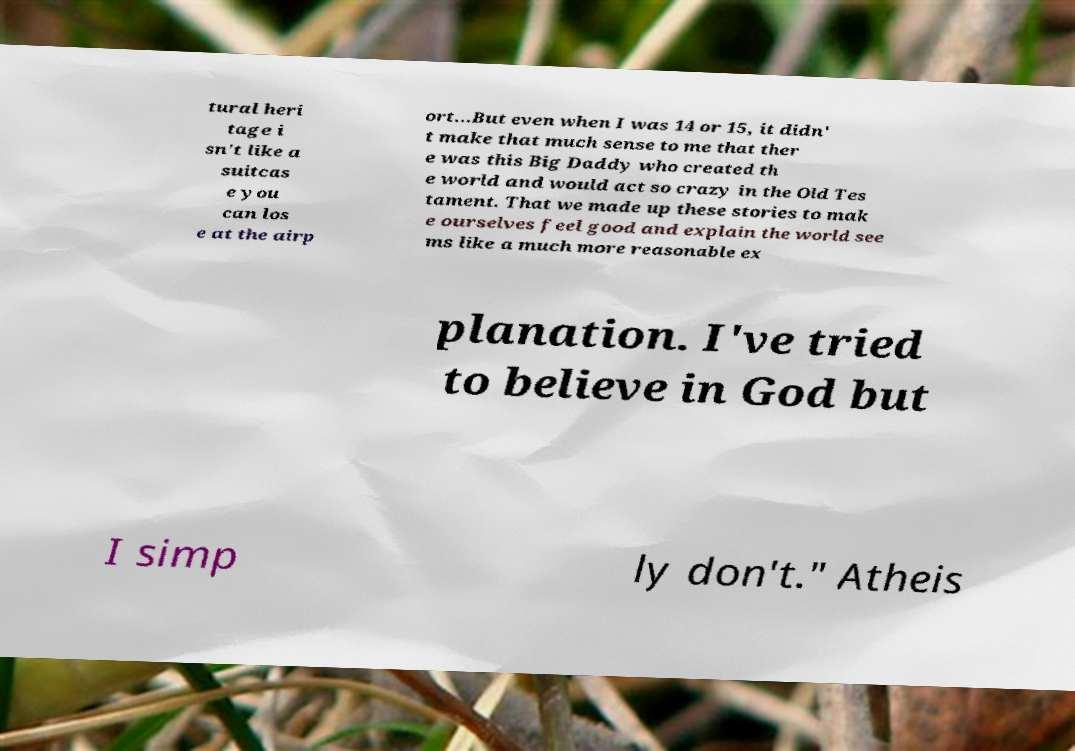Please read and relay the text visible in this image. What does it say? tural heri tage i sn't like a suitcas e you can los e at the airp ort...But even when I was 14 or 15, it didn' t make that much sense to me that ther e was this Big Daddy who created th e world and would act so crazy in the Old Tes tament. That we made up these stories to mak e ourselves feel good and explain the world see ms like a much more reasonable ex planation. I've tried to believe in God but I simp ly don't." Atheis 